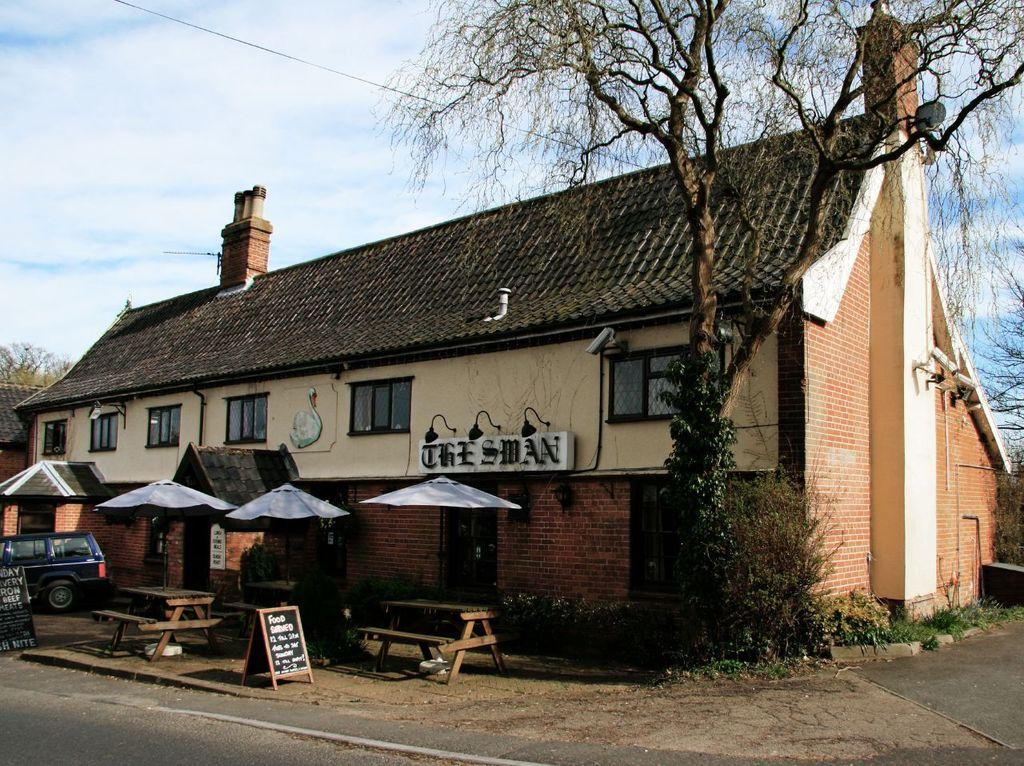What is the weather like in the image? The sky is cloudy in the image. Can you describe the building in the image? There is a building with a window and a roof top in the image. What objects are in front of the building? Umbrellas, a vehicle, a bench, a table, plants, and a bare tree are in front of the building. How many children are playing on the machine in the image? There is no machine or children present in the image. 